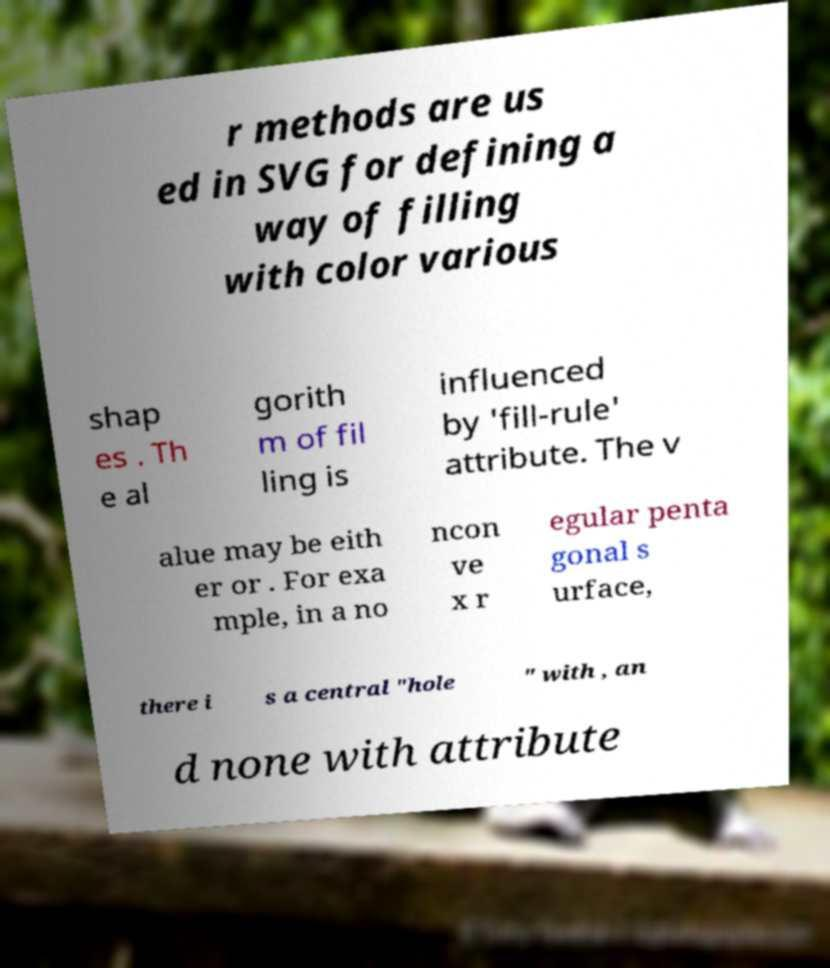I need the written content from this picture converted into text. Can you do that? r methods are us ed in SVG for defining a way of filling with color various shap es . Th e al gorith m of fil ling is influenced by 'fill-rule' attribute. The v alue may be eith er or . For exa mple, in a no ncon ve x r egular penta gonal s urface, there i s a central "hole " with , an d none with attribute 